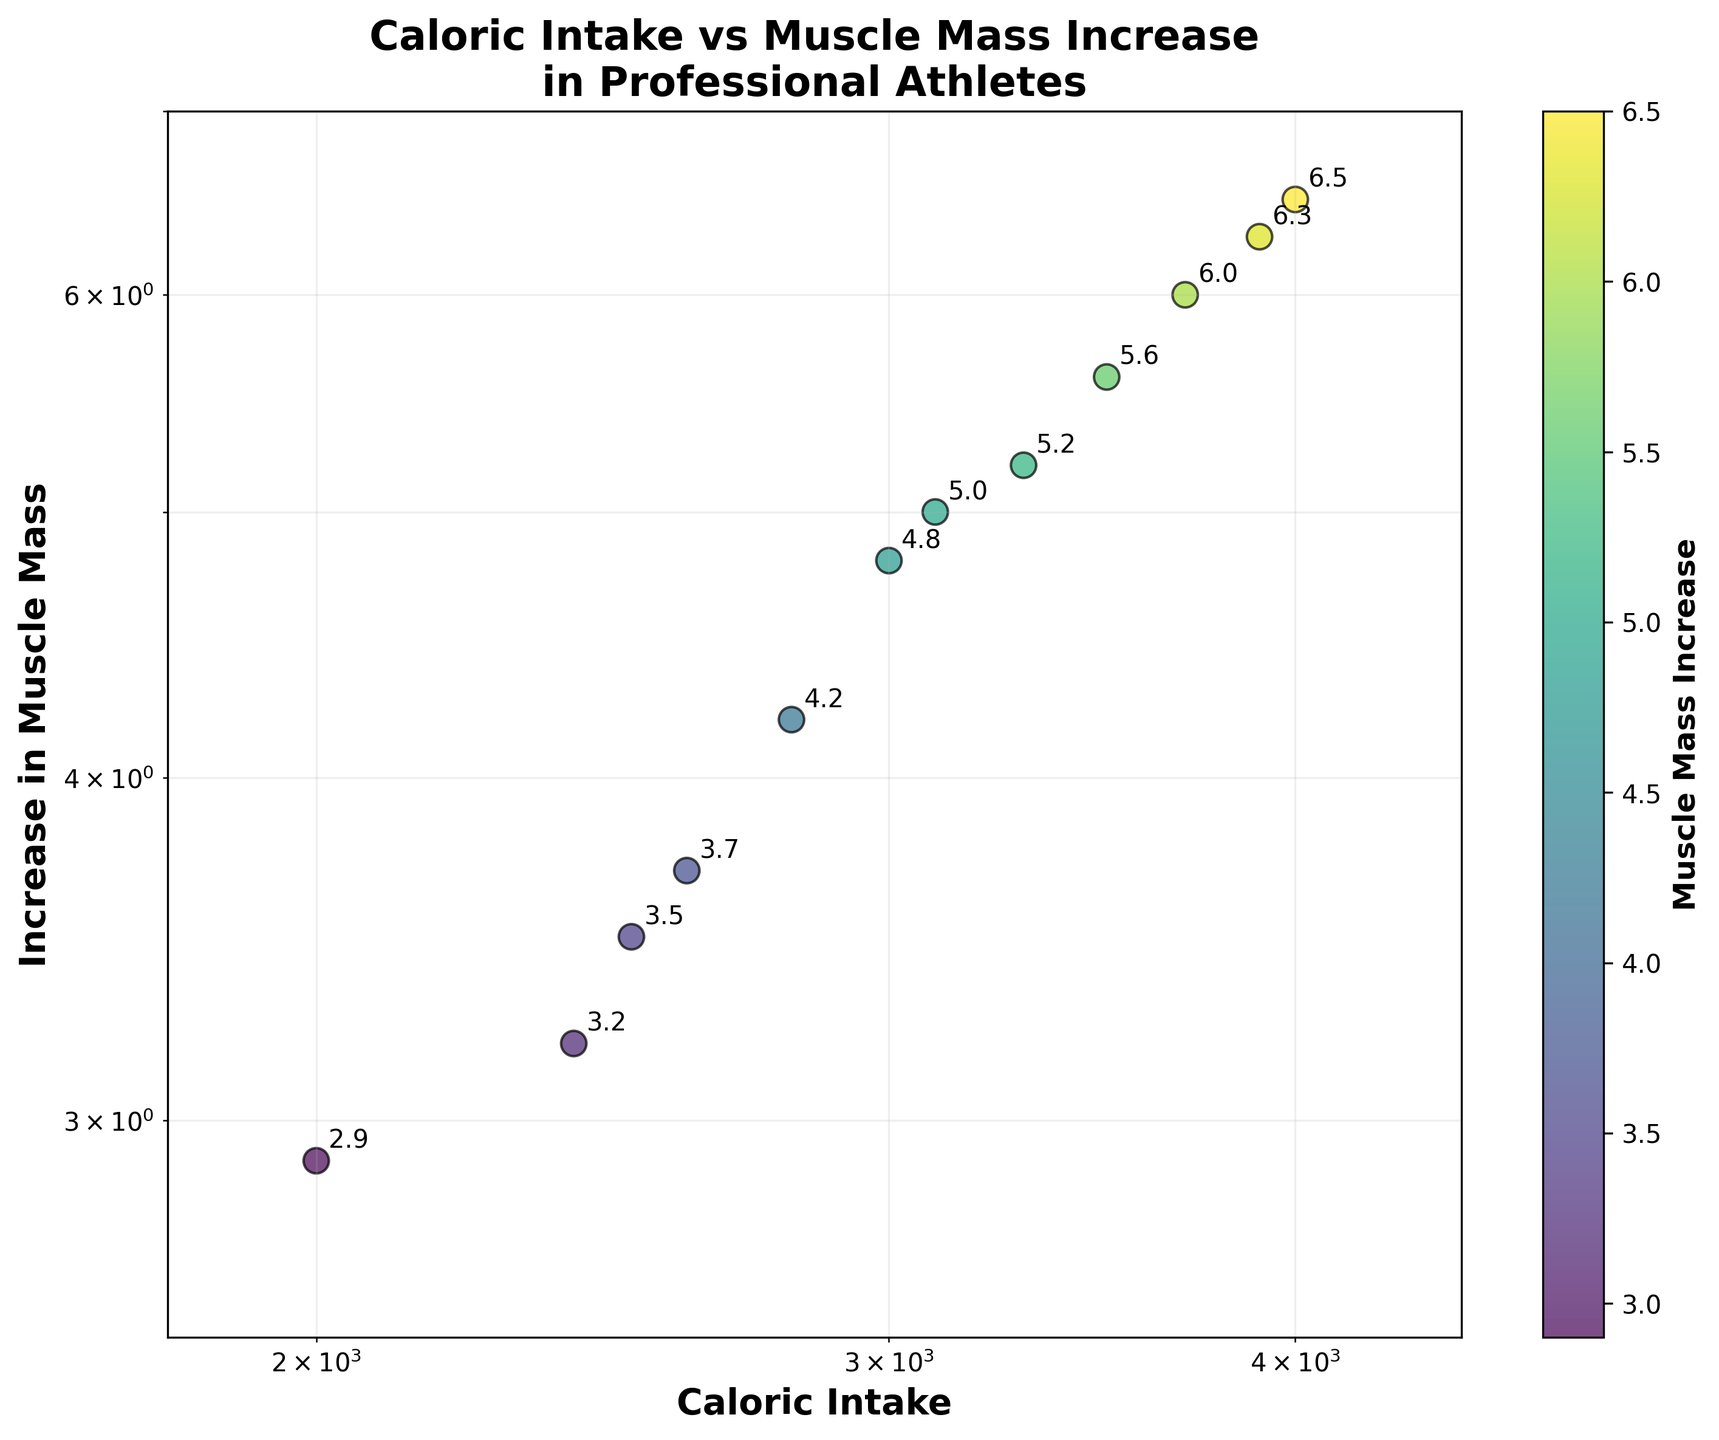What's the title of the figure? The title of the figure is mentioned at the top in bold lettering. The exact wording can be read directly from the figure.
Answer: "Caloric Intake vs Muscle Mass Increase in Professional Athletes" How many data points are shown in the scatter plot? To determine the number of data points, count the number of individual points visible in the scatter plot.
Answer: 12 What is the range of caloric intake displayed on the x-axis? The x-axis is labeled 'Caloric Intake,' and the range is determined by looking at the minimum and maximum values shown on this axis.
Answer: 1800 to 4500 Which data point has the highest increase in muscle mass? Identify the point that is highest on the y-axis, which represents 'Increase in Muscle Mass.'
Answer: 6.5 What is the muscle mass increase for an athlete with a caloric intake of approximately 3100? Find the data point closest to the value 3100 on the x-axis and look at its corresponding y-axis value.
Answer: 5.0 Is there a positive correlation between caloric intake and muscle mass increase? To assess correlation, observe the trend of the data points. If they generally move up along both axes, a positive correlation is present.
Answer: Yes What is the difference in muscle mass increase between athletes with caloric intakes of 2000 and 2800? Find the y-axis values for caloric intakes of 2000 and 2800, then subtract the smaller value from the larger one.
Answer: 4.2 - 2.9 = 1.3 On a log-log scale, are there any outliers, and if so, which one? An outlier is a point that does not fit the general pattern. On a log-log scale, compare the distances of points relative to the general trend.
Answer: No clear outliers What are the caloric intake values for athletes with a muscle mass increase greater than 6? Identify the points with y-axis values greater than 6 and note their corresponding x-axis values.
Answer: 3700, 3900, 4000 Do athletes with caloric intake between 3000 and 4000 have a consistent muscle mass increase? Look at the data points within the specified range on the x-axis and observe if their y-values are clustered closely.
Answer: Yes, they range between 4.8 and 6.5 